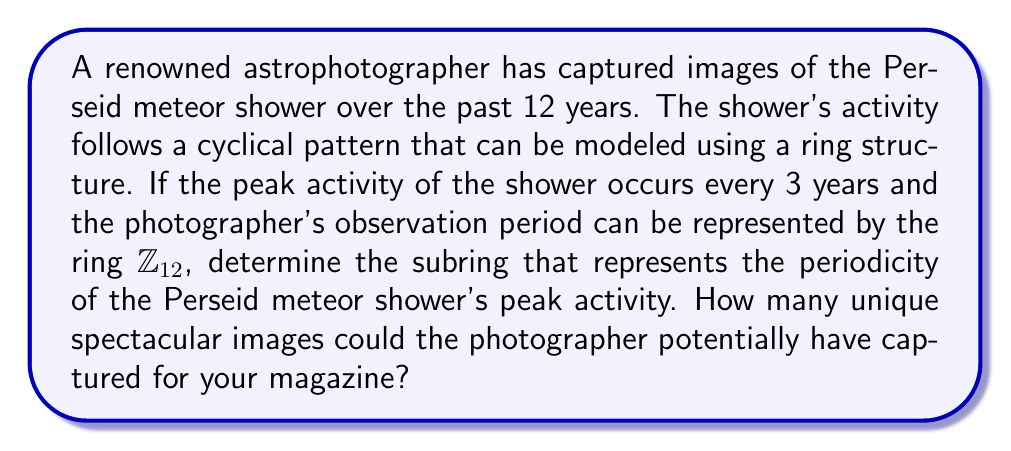Provide a solution to this math problem. To solve this problem, we need to analyze the periodicity of the Perseid meteor shower using ring theory concepts:

1) The photographer's observation period is represented by $\mathbb{Z}_{12}$, the ring of integers modulo 12.

2) The peak activity occurs every 3 years, which means we're looking for a subring with period 3 in $\mathbb{Z}_{12}$.

3) To find this subring, we need to identify the elements of $\mathbb{Z}_{12}$ that are multiples of 3:

   $S = \{0, 3, 6, 9\}$

4) We can verify that $S$ is indeed a subring of $\mathbb{Z}_{12}$:
   - It's closed under addition: $(3 + 6) \mod 12 = 9$, which is in $S$
   - It's closed under multiplication: $(3 \times 6) \mod 12 = 6$, which is in $S$
   - It contains the additive identity (0) and multiplicative identity (9)

5) This subring $S$ is isomorphic to $\mathbb{Z}_4$ under the mapping:
   $f: \mathbb{Z}_4 \to S$
   $f(x) = 3x \mod 12$

6) The order of this subring is 4, which means there are 4 distinct elements representing the peak activity years over the 12-year period.

7) Therefore, the photographer could have captured 4 unique spectacular images of peak Perseid meteor shower activity during their 12-year observation period.
Answer: The subring representing the periodicity of the Perseid meteor shower's peak activity is $S = \{0, 3, 6, 9\}$, which is isomorphic to $\mathbb{Z}_4$. The photographer could have potentially captured 4 unique spectacular images of peak activity for the magazine. 